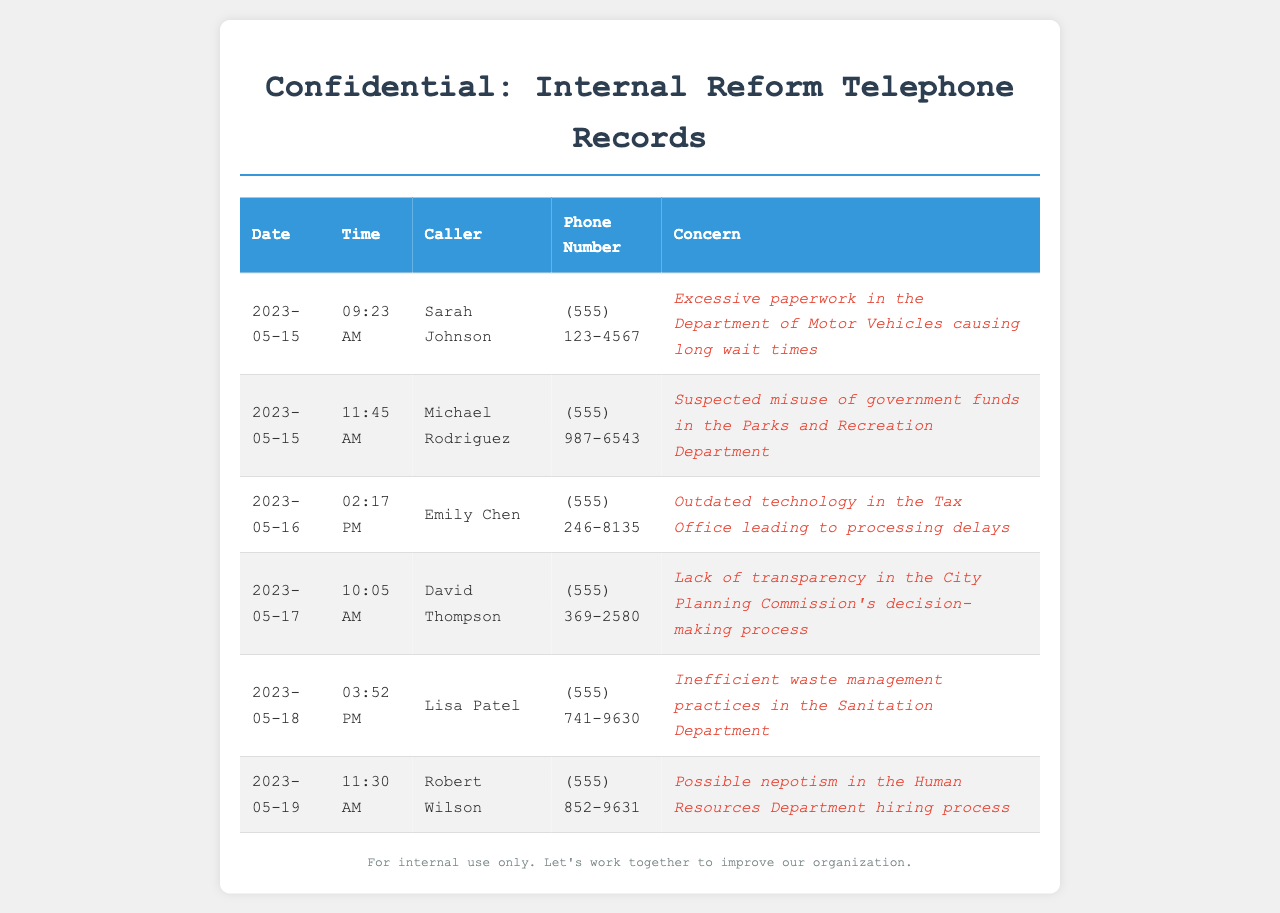What is the date of Sarah Johnson's call? The date of Sarah Johnson's call is listed in the first row of the table.
Answer: 2023-05-15 What is Michael Rodriguez's phone number? Michael Rodriguez's phone number is found in the second row of the table.
Answer: (555) 987-6543 What concern was reported by Emily Chen? Emily Chen's concern can be found in the third row of the table.
Answer: Outdated technology in the Tax Office leading to processing delays How many calls were made on May 18, 2023? There is only one entry for calls made on May 18, 2023, which is listed in the fifth row.
Answer: 1 Which caller reported issues regarding nepotism? The caller reporting issues regarding nepotism is referenced in the sixth row of the table.
Answer: Robert Wilson Which department was mentioned for excessive paperwork? The department mentioned for excessive paperwork is found in the first row concerning Sarah Johnson's call.
Answer: Department of Motor Vehicles What time did David Thompson make his call? The time of David Thompson's call can be found in the fourth row of the table.
Answer: 10:05 AM What was the date of the last recorded call? The date of the last recorded call is listed in the last entry of the table.
Answer: 2023-05-19 How many unique callers are listed in the document? The unique callers can be counted from each row in the table.
Answer: 6 